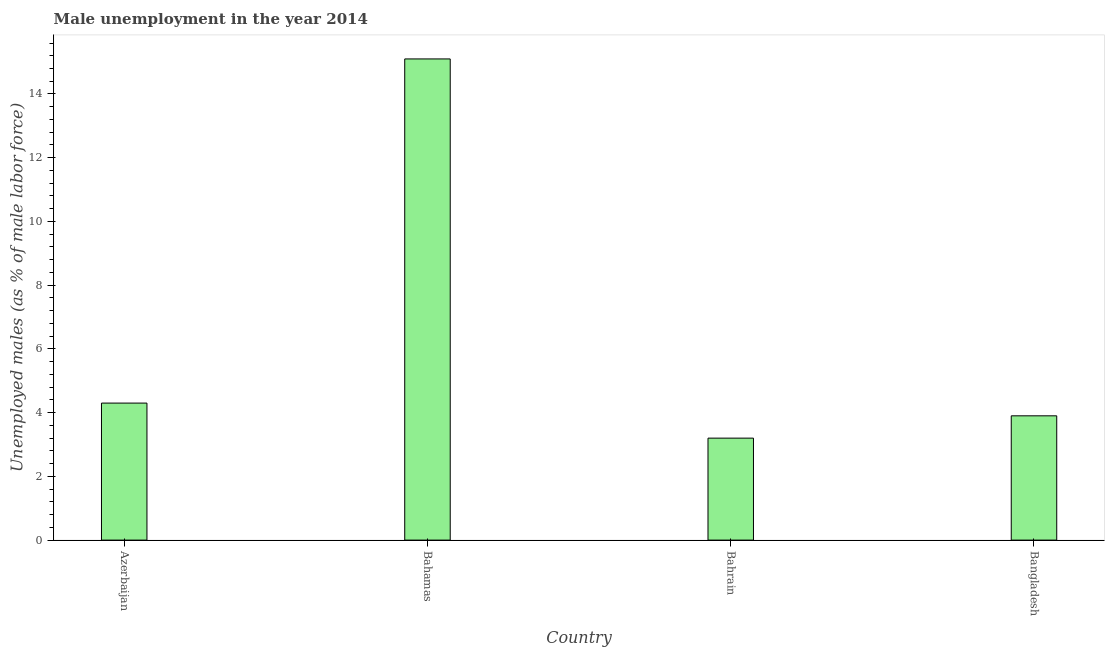Does the graph contain grids?
Your response must be concise. No. What is the title of the graph?
Your answer should be compact. Male unemployment in the year 2014. What is the label or title of the Y-axis?
Offer a very short reply. Unemployed males (as % of male labor force). What is the unemployed males population in Bahrain?
Provide a succinct answer. 3.2. Across all countries, what is the maximum unemployed males population?
Your answer should be compact. 15.1. Across all countries, what is the minimum unemployed males population?
Give a very brief answer. 3.2. In which country was the unemployed males population maximum?
Offer a very short reply. Bahamas. In which country was the unemployed males population minimum?
Ensure brevity in your answer.  Bahrain. What is the sum of the unemployed males population?
Keep it short and to the point. 26.5. What is the difference between the unemployed males population in Bahamas and Bangladesh?
Make the answer very short. 11.2. What is the average unemployed males population per country?
Give a very brief answer. 6.62. What is the median unemployed males population?
Keep it short and to the point. 4.1. What is the ratio of the unemployed males population in Azerbaijan to that in Bangladesh?
Offer a very short reply. 1.1. Is the unemployed males population in Azerbaijan less than that in Bangladesh?
Make the answer very short. No. What is the difference between the highest and the second highest unemployed males population?
Keep it short and to the point. 10.8. What is the difference between the highest and the lowest unemployed males population?
Offer a terse response. 11.9. How many countries are there in the graph?
Make the answer very short. 4. What is the difference between two consecutive major ticks on the Y-axis?
Provide a short and direct response. 2. What is the Unemployed males (as % of male labor force) of Azerbaijan?
Your answer should be compact. 4.3. What is the Unemployed males (as % of male labor force) of Bahamas?
Your response must be concise. 15.1. What is the Unemployed males (as % of male labor force) in Bahrain?
Your answer should be very brief. 3.2. What is the Unemployed males (as % of male labor force) of Bangladesh?
Your answer should be very brief. 3.9. What is the difference between the Unemployed males (as % of male labor force) in Azerbaijan and Bahamas?
Make the answer very short. -10.8. What is the difference between the Unemployed males (as % of male labor force) in Azerbaijan and Bahrain?
Your answer should be compact. 1.1. What is the difference between the Unemployed males (as % of male labor force) in Azerbaijan and Bangladesh?
Your response must be concise. 0.4. What is the difference between the Unemployed males (as % of male labor force) in Bahamas and Bahrain?
Make the answer very short. 11.9. What is the difference between the Unemployed males (as % of male labor force) in Bahamas and Bangladesh?
Give a very brief answer. 11.2. What is the difference between the Unemployed males (as % of male labor force) in Bahrain and Bangladesh?
Keep it short and to the point. -0.7. What is the ratio of the Unemployed males (as % of male labor force) in Azerbaijan to that in Bahamas?
Provide a succinct answer. 0.28. What is the ratio of the Unemployed males (as % of male labor force) in Azerbaijan to that in Bahrain?
Make the answer very short. 1.34. What is the ratio of the Unemployed males (as % of male labor force) in Azerbaijan to that in Bangladesh?
Give a very brief answer. 1.1. What is the ratio of the Unemployed males (as % of male labor force) in Bahamas to that in Bahrain?
Your response must be concise. 4.72. What is the ratio of the Unemployed males (as % of male labor force) in Bahamas to that in Bangladesh?
Your response must be concise. 3.87. What is the ratio of the Unemployed males (as % of male labor force) in Bahrain to that in Bangladesh?
Make the answer very short. 0.82. 